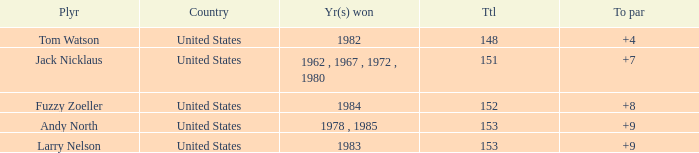What is the To par of the Player wtih Year(s) won of 1983? 9.0. 